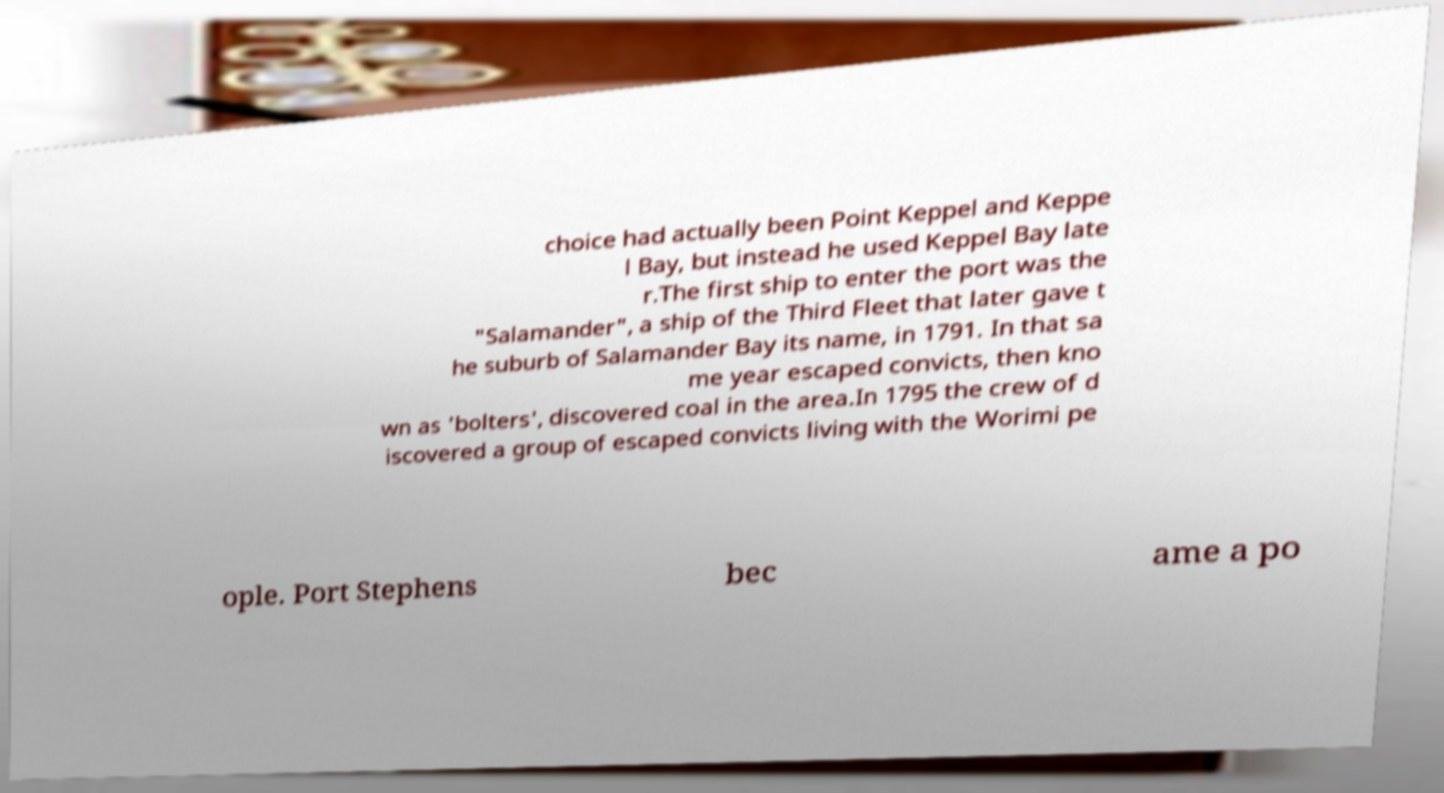Can you read and provide the text displayed in the image?This photo seems to have some interesting text. Can you extract and type it out for me? choice had actually been Point Keppel and Keppe l Bay, but instead he used Keppel Bay late r.The first ship to enter the port was the "Salamander", a ship of the Third Fleet that later gave t he suburb of Salamander Bay its name, in 1791. In that sa me year escaped convicts, then kno wn as 'bolters', discovered coal in the area.In 1795 the crew of d iscovered a group of escaped convicts living with the Worimi pe ople. Port Stephens bec ame a po 